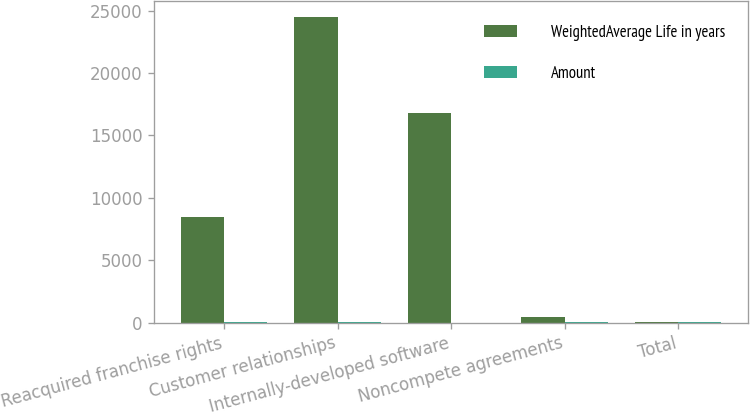<chart> <loc_0><loc_0><loc_500><loc_500><stacked_bar_chart><ecel><fcel>Reacquired franchise rights<fcel>Customer relationships<fcel>Internally-developed software<fcel>Noncompete agreements<fcel>Total<nl><fcel>WeightedAverage Life in years<fcel>8480<fcel>24518<fcel>16821<fcel>453<fcel>6<nl><fcel>Amount<fcel>5<fcel>6<fcel>2<fcel>5<fcel>4<nl></chart> 